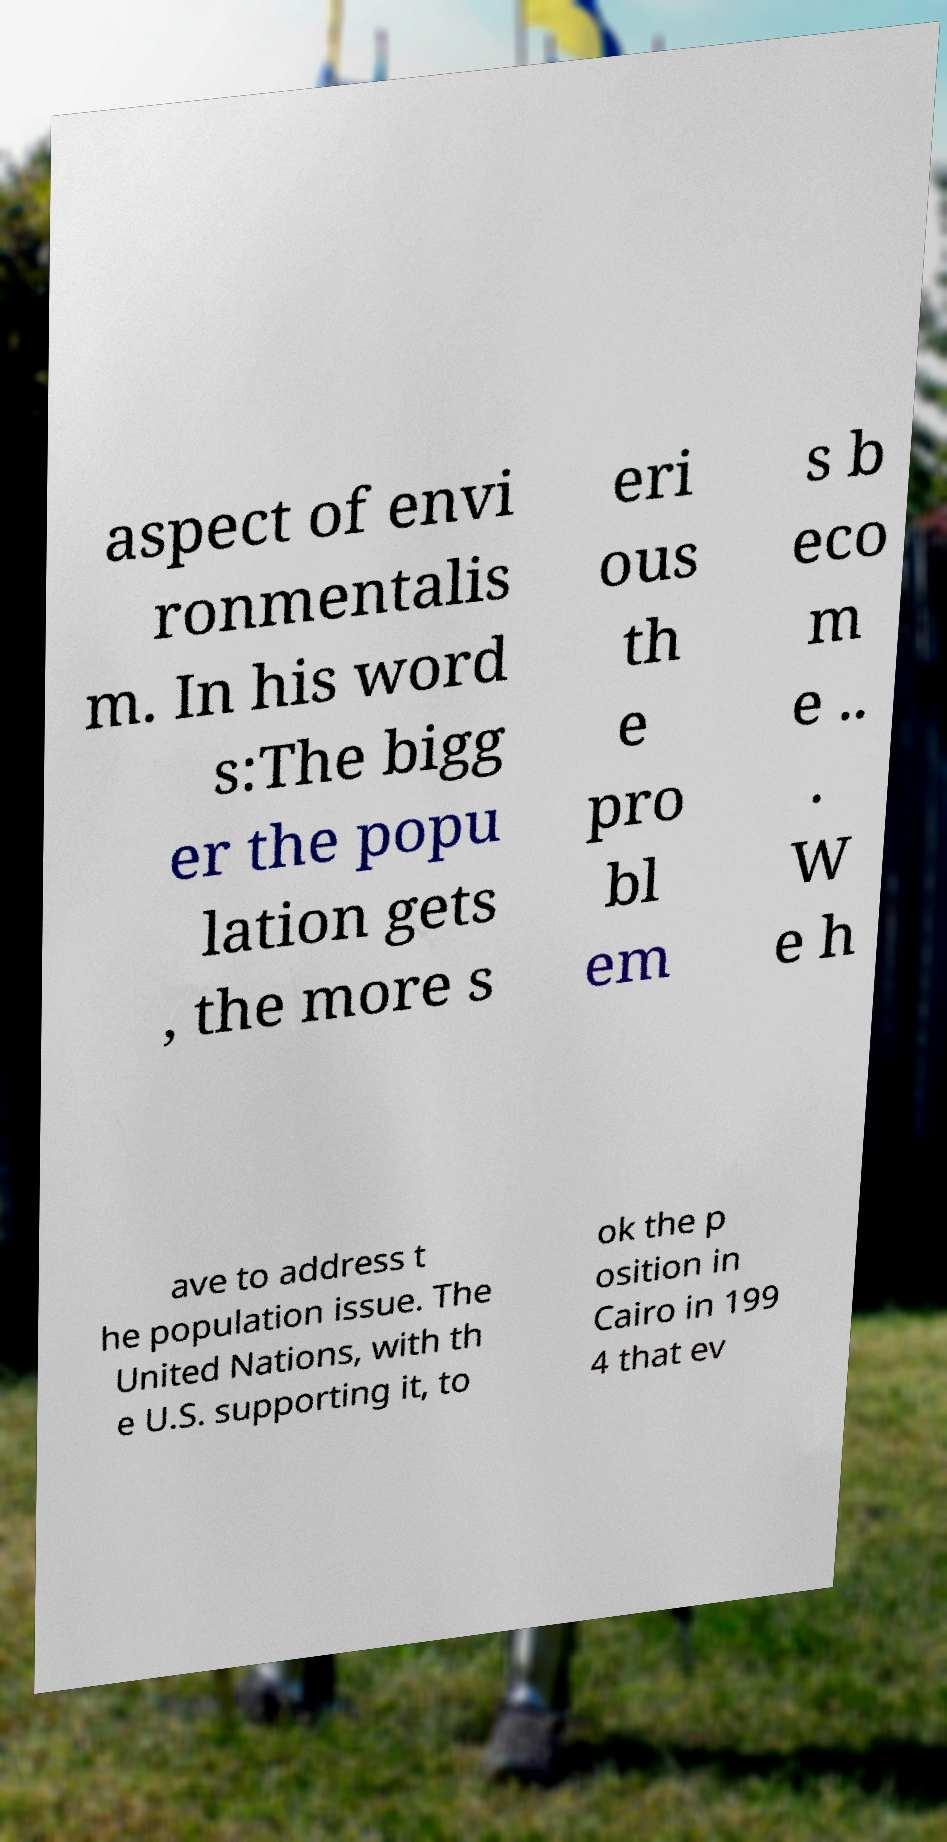Can you read and provide the text displayed in the image?This photo seems to have some interesting text. Can you extract and type it out for me? aspect of envi ronmentalis m. In his word s:The bigg er the popu lation gets , the more s eri ous th e pro bl em s b eco m e .. . W e h ave to address t he population issue. The United Nations, with th e U.S. supporting it, to ok the p osition in Cairo in 199 4 that ev 